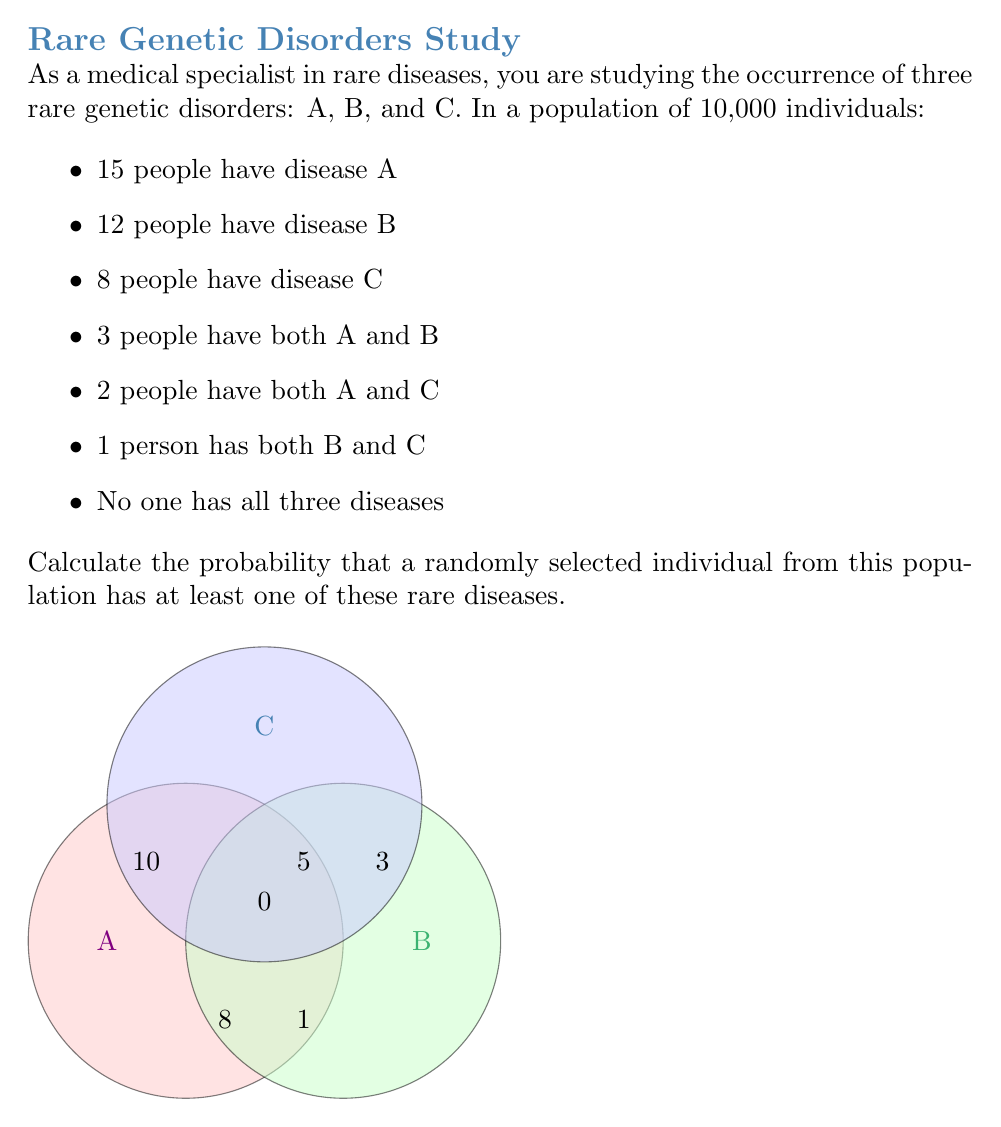What is the answer to this math problem? Let's approach this step-by-step using set theory:

1) First, we need to find the total number of people with at least one disease. We can use the inclusion-exclusion principle:

   $$|A \cup B \cup C| = |A| + |B| + |C| - |A \cap B| - |A \cap C| - |B \cap C| + |A \cap B \cap C|$$

2) We know:
   $|A| = 15$, $|B| = 12$, $|C| = 8$
   $|A \cap B| = 3$, $|A \cap C| = 2$, $|B \cap C| = 1$
   $|A \cap B \cap C| = 0$

3) Substituting these values:

   $$|A \cup B \cup C| = 15 + 12 + 8 - 3 - 2 - 1 + 0 = 29$$

4) So, 29 people have at least one of these rare diseases.

5) The probability is the number of favorable outcomes divided by the total number of possible outcomes:

   $$P(\text{at least one disease}) = \frac{\text{number of people with at least one disease}}{\text{total population}}$$

6) Substituting the values:

   $$P(\text{at least one disease}) = \frac{29}{10000} = 0.0029$$
Answer: $\frac{29}{10000}$ or $0.0029$ or $0.29\%$ 